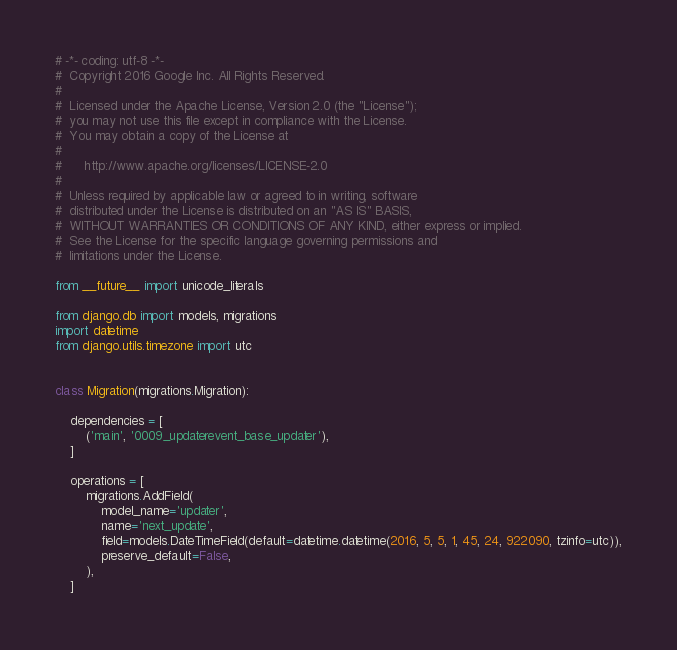<code> <loc_0><loc_0><loc_500><loc_500><_Python_># -*- coding: utf-8 -*-
#  Copyright 2016 Google Inc. All Rights Reserved.
#  
#  Licensed under the Apache License, Version 2.0 (the "License");
#  you may not use this file except in compliance with the License.
#  You may obtain a copy of the License at
#  
#      http://www.apache.org/licenses/LICENSE-2.0
#  
#  Unless required by applicable law or agreed to in writing, software
#  distributed under the License is distributed on an "AS IS" BASIS,
#  WITHOUT WARRANTIES OR CONDITIONS OF ANY KIND, either express or implied.
#  See the License for the specific language governing permissions and
#  limitations under the License. 

from __future__ import unicode_literals

from django.db import models, migrations
import datetime
from django.utils.timezone import utc


class Migration(migrations.Migration):

    dependencies = [
        ('main', '0009_updaterevent_base_updater'),
    ]

    operations = [
        migrations.AddField(
            model_name='updater',
            name='next_update',
            field=models.DateTimeField(default=datetime.datetime(2016, 5, 5, 1, 45, 24, 922090, tzinfo=utc)),
            preserve_default=False,
        ),
    ]
</code> 